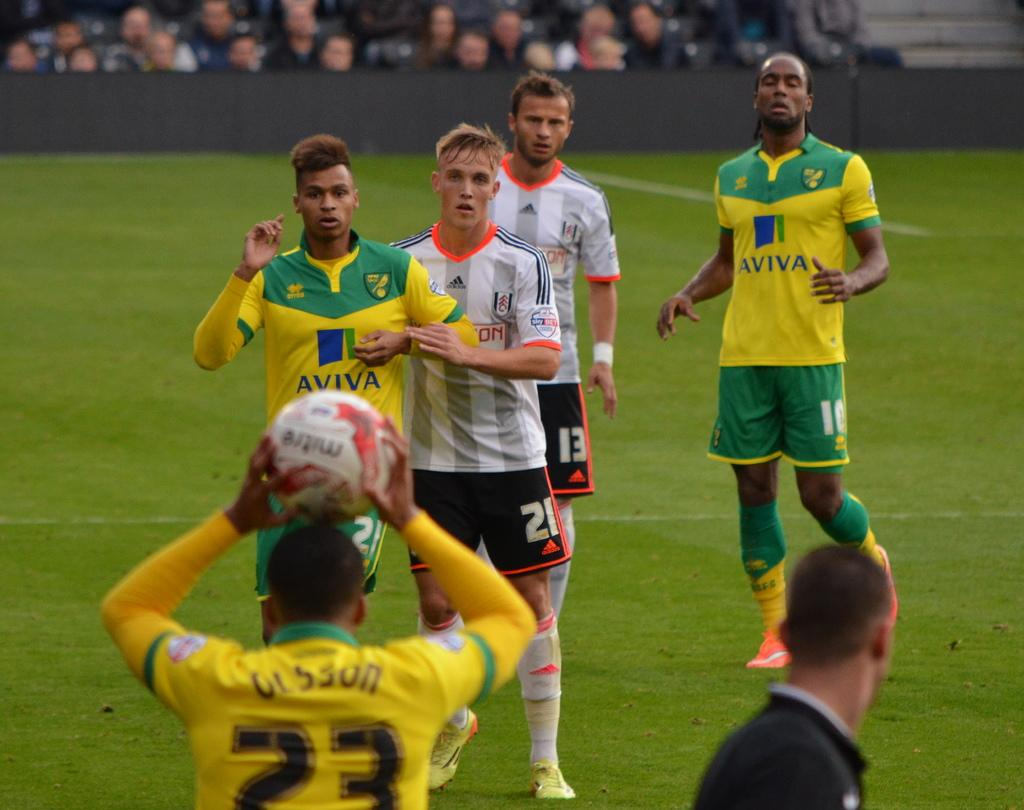What is: What are the two teams in the image doing? They are playing with a ball in the image. Where is the game taking place? The game is taking place on a ground. Can you describe the people in the background of the image? There is an audience in the background of the image, and they are watching the match. What language is the ant speaking to the audience in the image? There is no ant present in the image, so it is not possible to determine what language it might be speaking. 